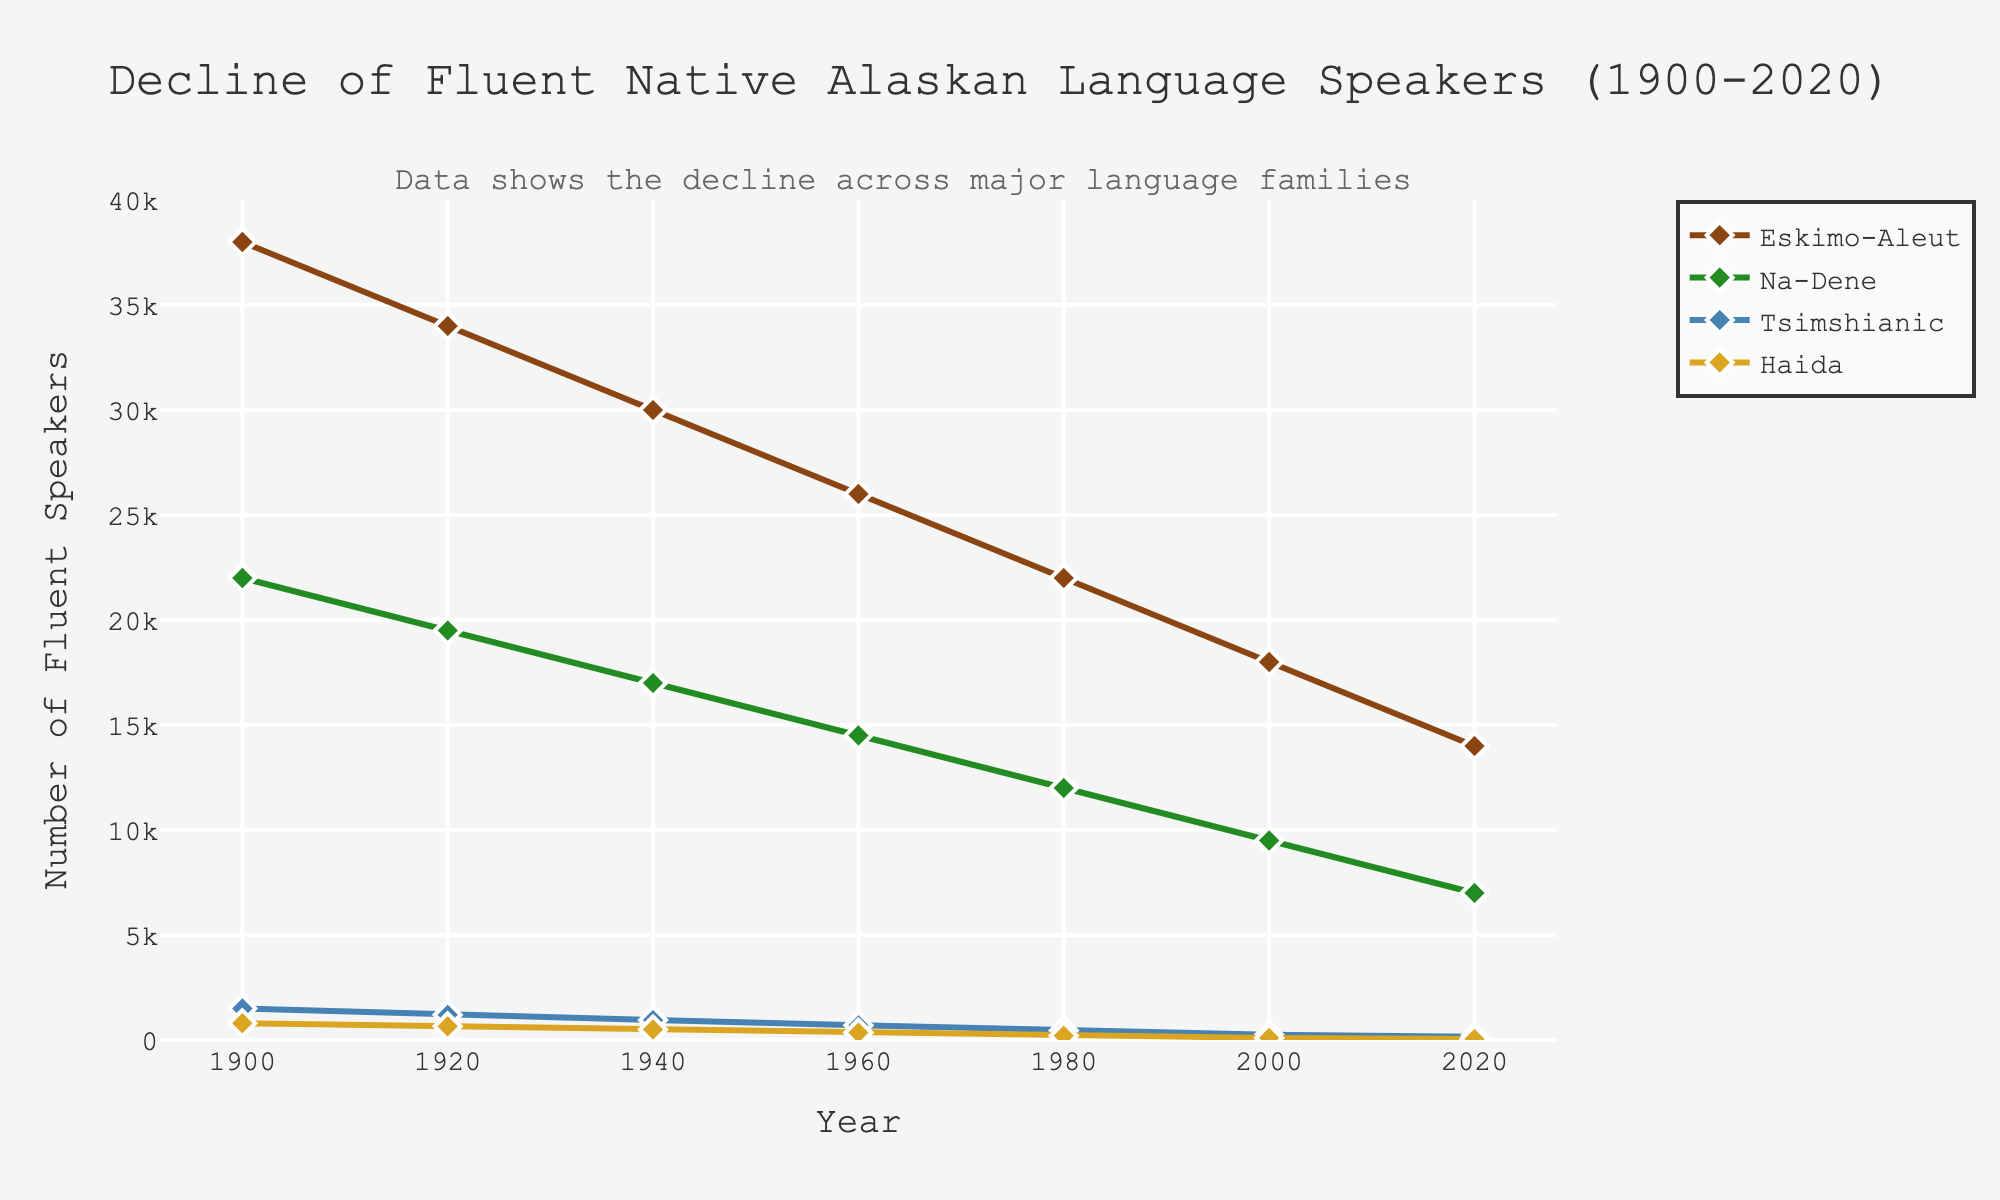Which language family has the highest number of fluent speakers in 1900? The highest line on the graph in 1900 represents the Eskimo-Aleut language family.
Answer: Eskimo-Aleut By how much did the number of fluent Tsimshianic speakers decline from 1900 to 2020? In 1900, there were 1500 fluent speakers, and in 2020, there were 150. The decline can be calculated as 1500 - 150 = 1350.
Answer: 1350 Which year shows the smallest gap between the number of fluent Eskimo-Aleut and Na-Dene speakers? The smallest gap is observed around 2020 where the lines for Eskimo-Aleut and Na-Dene are closest, with a difference of 14000 - 7000 = 7000.
Answer: 2020 If the trend continues, in how many years will the number of fluent Haida speakers reach zero? The number of fluent Haida speakers is decreasing steadily. Extrapolating from 100 in 2000 to 50 in 2020, a drop of approximately 50 in 20 years, it will take another 20 years to reach zero. So from 2020, it will be around 2040.
Answer: 2040 What is the average percentage decrease per decade for the Na-Dene speakers between 1900 and 2020? Starting from 22000 in 1900 to 7000 in 2020. The total decrease is 22000 - 7000 = 15000. Over 12 decades (120 years), the average decrease per decade is 15000/120 * 10 = 1250. To find the percentage decrease: (1250/22000) * 100 ≈ 5.68%.
Answer: 5.68% Compare the rate of decline between Eskimo-Aleut and Haida speakers from 1900 to 2020. Which declined faster? From 38000 to 14000 for Eskimo-Aleut (a decline of 24000) and from 800 to 50 for Haida (a decline of 750). Although Haida has a smaller absolute decline, the relative percentage change is higher (750/800*100 ≈ 93.75%) compared to Eskimo-Aleut (24000/38000*100 ≈ 63.16%).
Answer: Haida What's the total number of fluent speakers across all language families in 2020? Summing the number of fluent speakers in 2020 across all language families: 14000 (Eskimo-Aleut) + 7000 (Na-Dene) + 150 (Tsimshianic) + 50 (Haida) = 21200.
Answer: 21200 